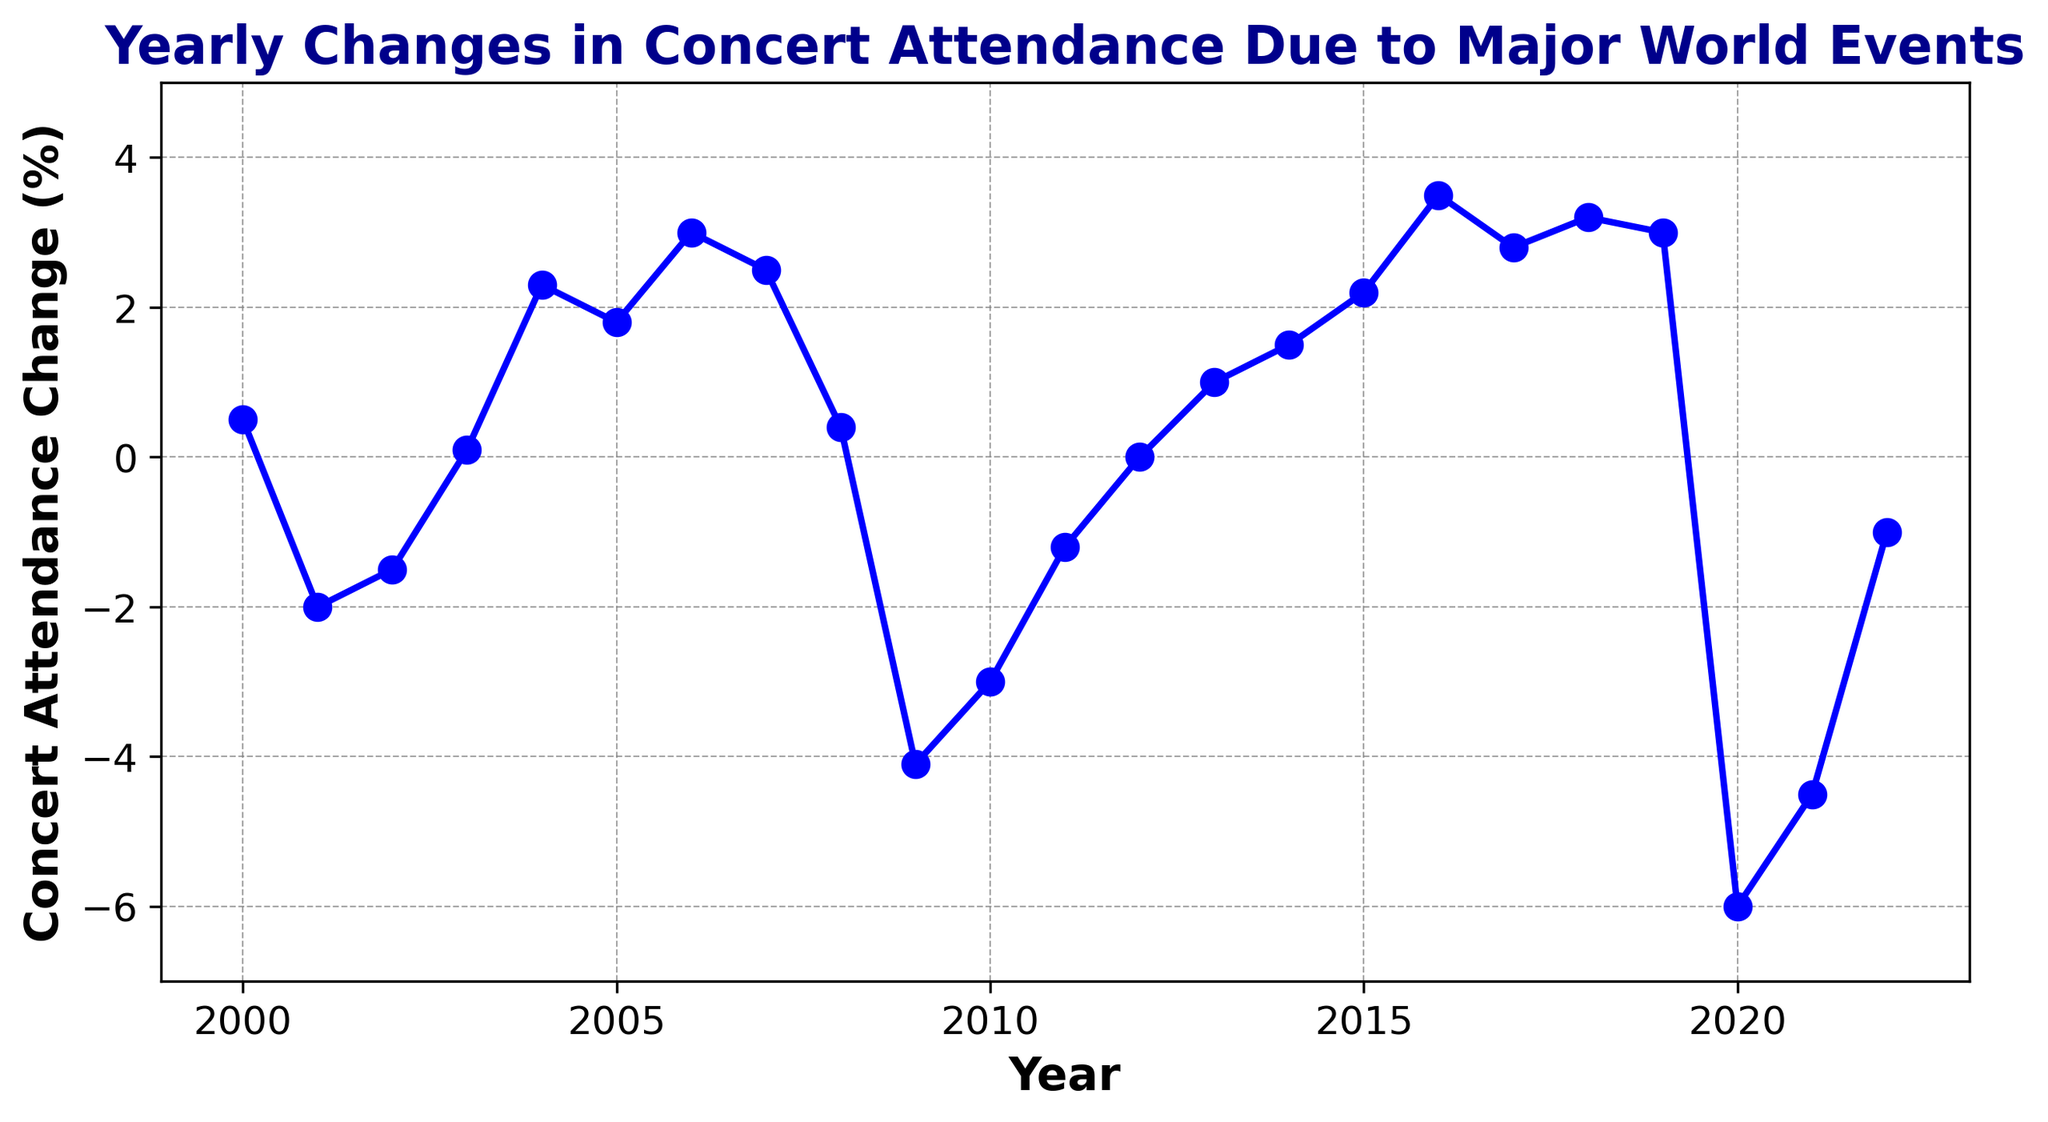What was the concert attendance change in 2020? To determine the concert attendance change in 2020, look for the data point for the year 2020 on the x-axis. The value associated with it on the line chart is the change in percentage.
Answer: -6.0% Which year experienced the largest negative change in concert attendance? The largest negative change is identified by finding the lowest point on the line chart. The year where the attendance change is the most negative is where the line dips the furthest below zero.
Answer: 2020 How did concert attendance change between 2009 and 2010? Subtract the concert attendance change of 2009 from the change in 2010. The values are -4.1% for 2009 and -3.0% for 2010, so the difference is -3.0 - (-4.1) = 1.1%.
Answer: 1.1% Compare the concert attendance change in the years 2004 and 2022. To compare these two years, check the values from the line chart; 2004 shows an increase of 2.3% and 2022 shows a decrease of -1.0%. Therefore, 2004 had a higher attendance change compared to 2022.
Answer: 2004 had a higher change What was the trend in concert attendance changes from 2018 to 2020? Observing the line chart from 2018 to 2020, we see that the attendance change decreases from 3.2% in 2018 to 3.0% in 2019, and then sharply drops to -6.0% in 2020. This indicates an initial slight decrease followed by a significant drop.
Answer: Decrease What is the average concert attendance change between 2000 and 2006? Sum the attendance changes from 2000 to 2006 and then divide by the number of years. The values are 0.5, -2.0, -1.5, 0.1, 2.3, 1.8, 3.0. Sum = 0.5 + (-2.0) + (-1.5) + 0.1 + 2.3 + 1.8 + 3.0 = 4.2. The average is 4.2 / 7 ≈ 0.6%.
Answer: 0.6% During which period did the concert attendance improve continuously for the longest time? Look for the longest sequence of consecutive years on the line chart where the attendance change increases. From 2015 to 2018, each subsequent year shows an increase in attendance change: 2.2% in 2015, 3.5% in 2016, 2.8% in 2017, and 3.2% in 2018.
Answer: 2015-2018 What is the median concert attendance change over the entire data range? List all annual attendance changes, sort them, and find the middle value. Sorted data: -6.0, -4.5, -4.1, -3.0, -2.0, -1.5, -1.2, -1.0, 0.0, 0.1, 0.4, 0.5, 1.0, 1.5, 1.8, 2.2, 2.3, 2.5, 2.8, 3.0, 3.0, 3.2, 3.5. Median is the 12th value: 0.4%.
Answer: 0.4% By how much did the concert attendance change in 2021 differ from the change in 2022? Find the difference between the two years' changes. 2021 has a change of -4.5% and 2022 has -1.0%. The difference is -4.5 - (-1.0) = -3.5%.
Answer: 3.5% Identify the years with a positive increase in concert attendance following a year with a negative change. Review the line chart to identify years where a positive change follows a negative one. Examples include: 2003 (0.1% after -1.5%), 2012 (0.0% after -1.2%), 2013 (1.0% after 0.0%), 2014 (1.5% after 1.0%).
Answer: 2003, 2012, 2013, 2014 